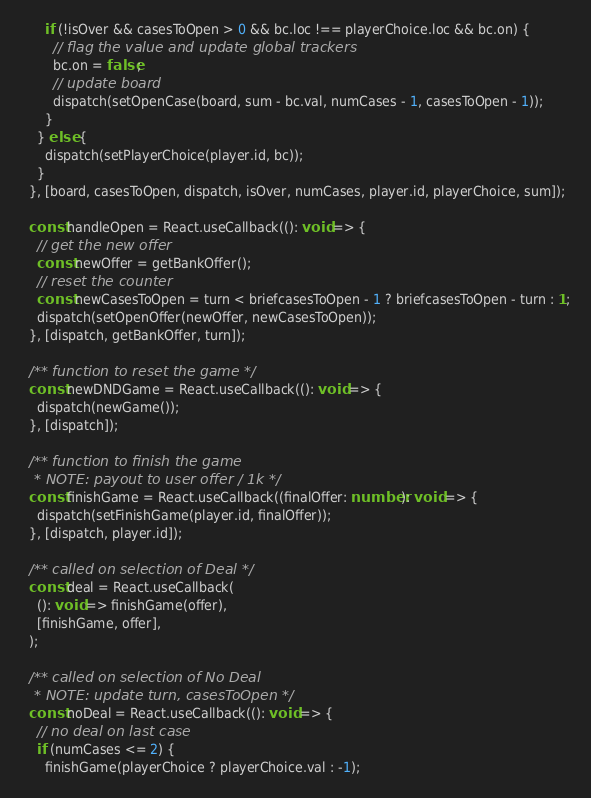<code> <loc_0><loc_0><loc_500><loc_500><_TypeScript_>      if (!isOver && casesToOpen > 0 && bc.loc !== playerChoice.loc && bc.on) {
        // flag the value and update global trackers
        bc.on = false;
        // update board
        dispatch(setOpenCase(board, sum - bc.val, numCases - 1, casesToOpen - 1));
      }
    } else {
      dispatch(setPlayerChoice(player.id, bc));
    }
  }, [board, casesToOpen, dispatch, isOver, numCases, player.id, playerChoice, sum]);

  const handleOpen = React.useCallback((): void => {
    // get the new offer
    const newOffer = getBankOffer();
    // reset the counter
    const newCasesToOpen = turn < briefcasesToOpen - 1 ? briefcasesToOpen - turn : 1;
    dispatch(setOpenOffer(newOffer, newCasesToOpen));
  }, [dispatch, getBankOffer, turn]);

  /** function to reset the game */
  const newDNDGame = React.useCallback((): void => {
    dispatch(newGame());
  }, [dispatch]);

  /** function to finish the game
   * NOTE: payout to user offer / 1k */
  const finishGame = React.useCallback((finalOffer: number): void => {
    dispatch(setFinishGame(player.id, finalOffer));
  }, [dispatch, player.id]);

  /** called on selection of Deal */
  const deal = React.useCallback(
    (): void => finishGame(offer),
    [finishGame, offer],
  );

  /** called on selection of No Deal
   * NOTE: update turn, casesToOpen */
  const noDeal = React.useCallback((): void => {
    // no deal on last case
    if (numCases <= 2) {
      finishGame(playerChoice ? playerChoice.val : -1);</code> 